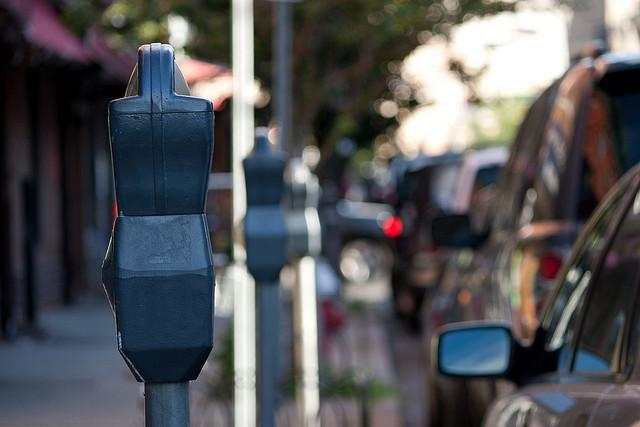What is to the left of the cars? parking meter 